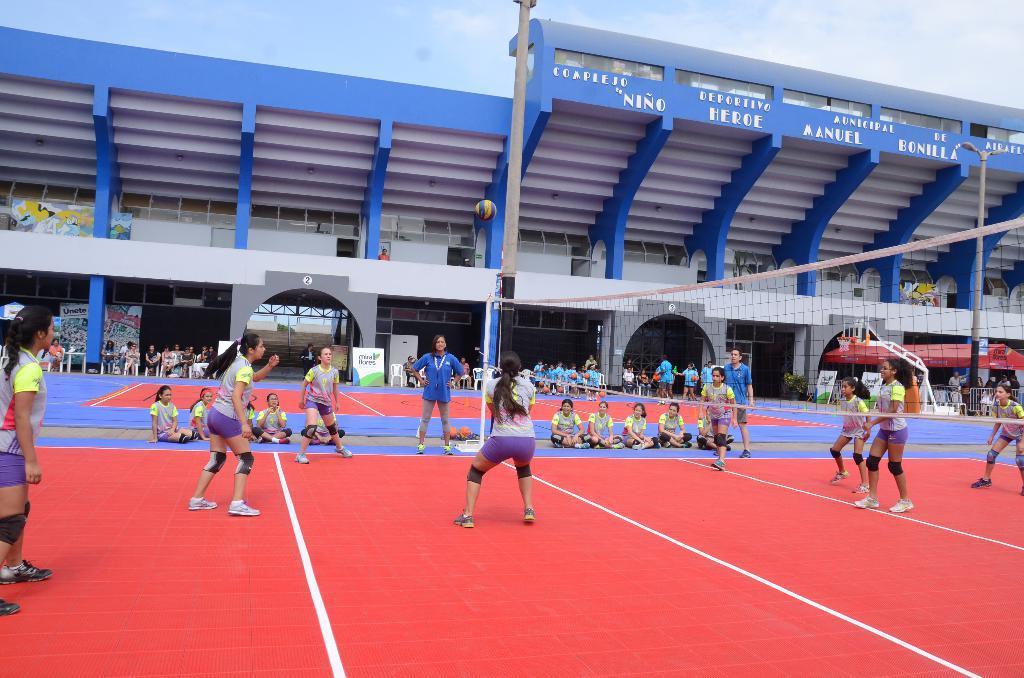How many people are in the image? There is a group of people in the image, but the exact number cannot be determined from the provided facts. What object is present in the image that is typically used for catching or blocking? There is a net in the image. What can be seen in the background of the image? There is a building and the sky visible in the background of the image. What type of toothpaste is being used by the people in the image? There is no toothpaste present in the image. How many cubs are visible in the image? There are no cubs present in the image. 